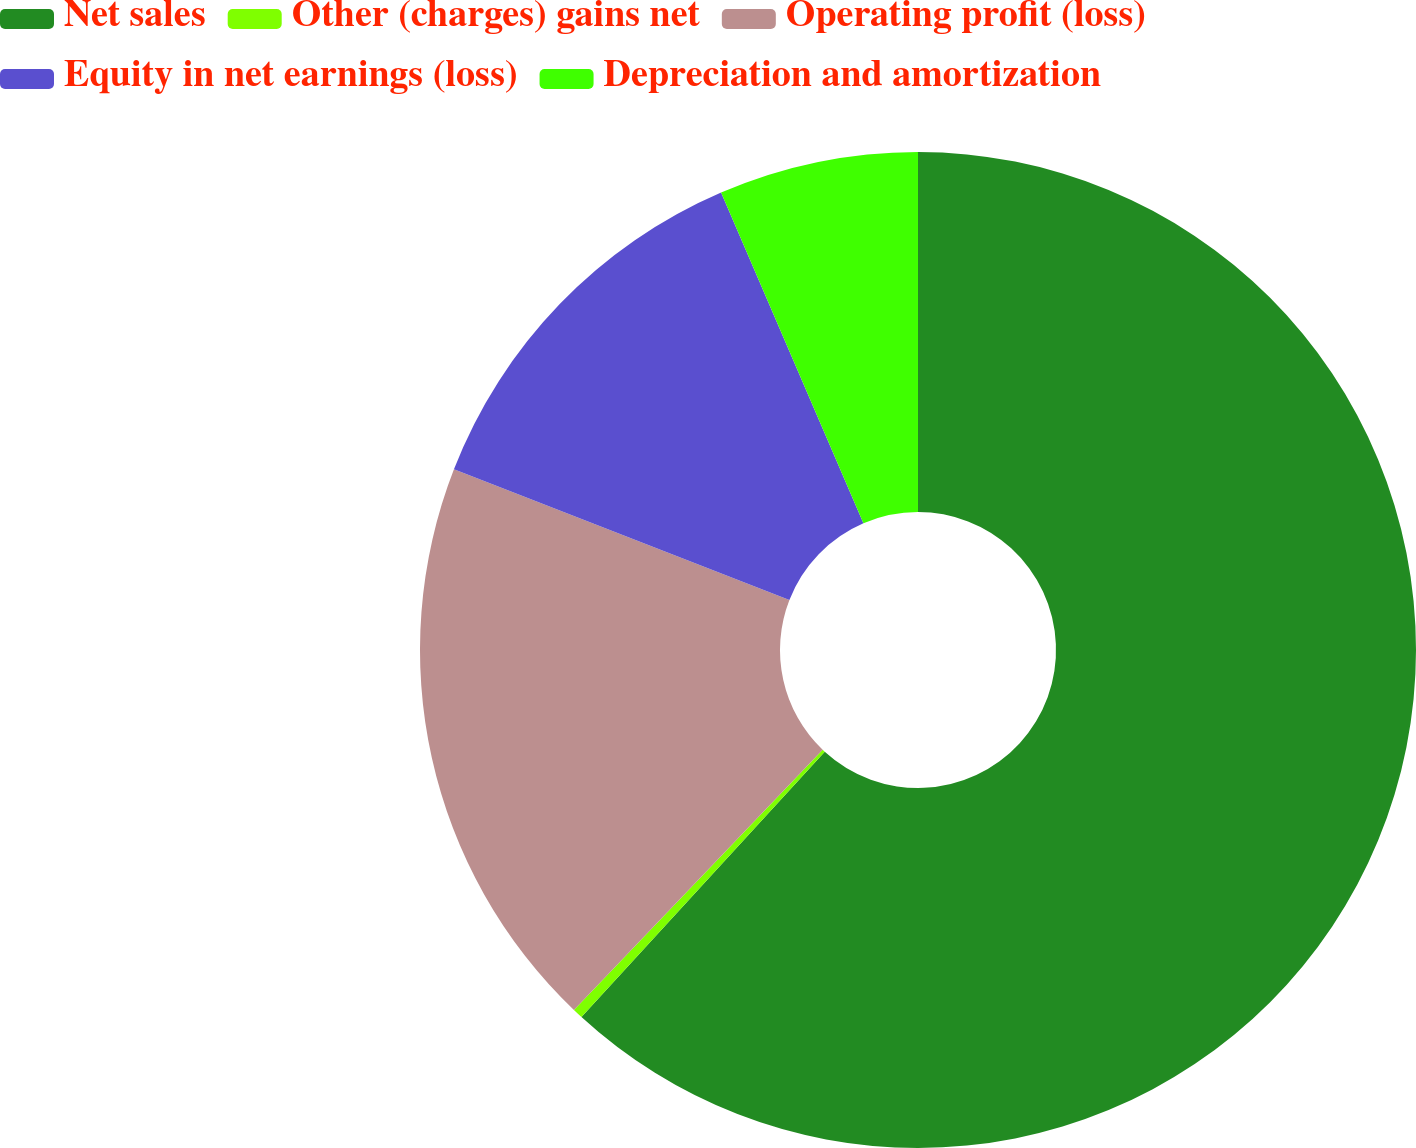<chart> <loc_0><loc_0><loc_500><loc_500><pie_chart><fcel>Net sales<fcel>Other (charges) gains net<fcel>Operating profit (loss)<fcel>Equity in net earnings (loss)<fcel>Depreciation and amortization<nl><fcel>61.81%<fcel>0.33%<fcel>18.77%<fcel>12.62%<fcel>6.47%<nl></chart> 